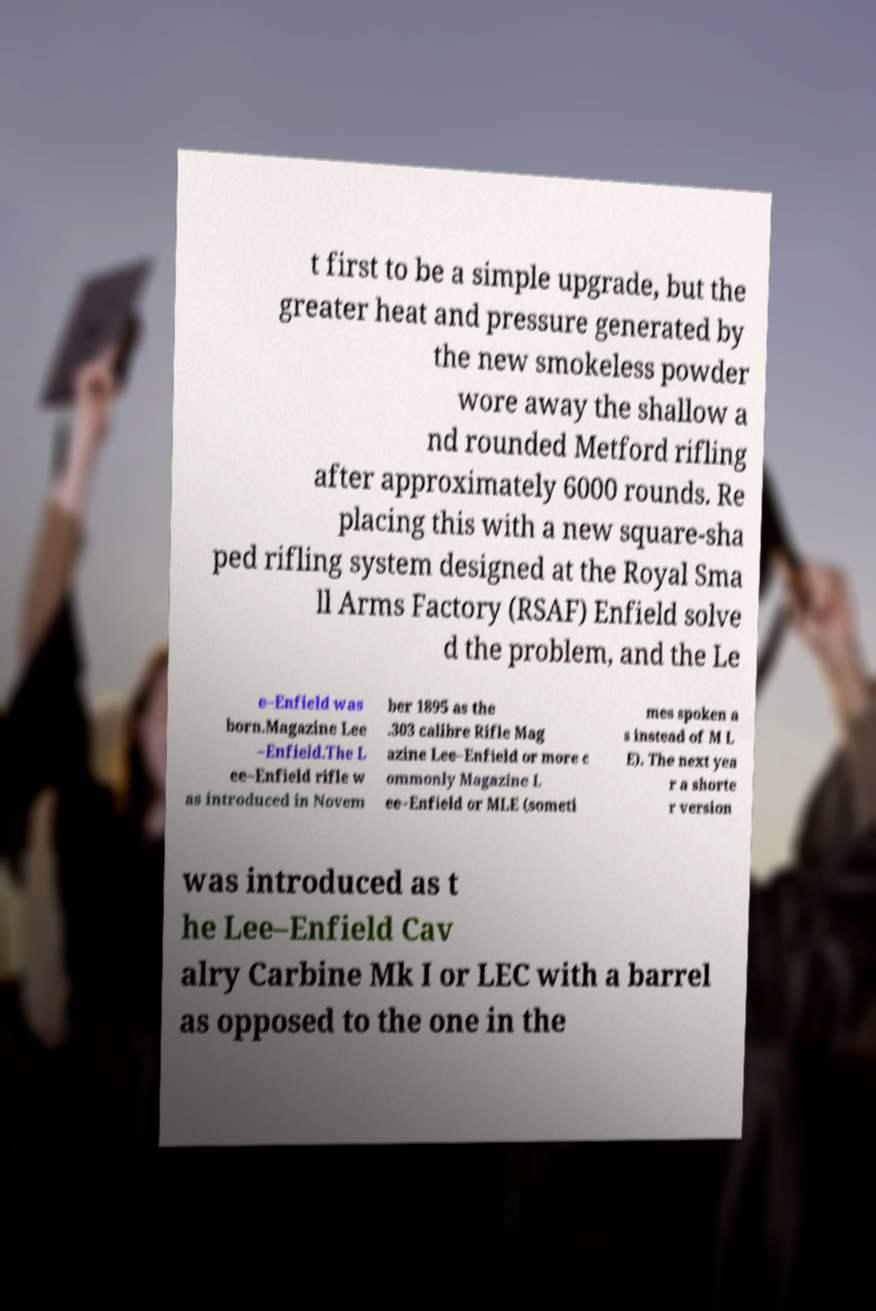Could you assist in decoding the text presented in this image and type it out clearly? t first to be a simple upgrade, but the greater heat and pressure generated by the new smokeless powder wore away the shallow a nd rounded Metford rifling after approximately 6000 rounds. Re placing this with a new square-sha ped rifling system designed at the Royal Sma ll Arms Factory (RSAF) Enfield solve d the problem, and the Le e–Enfield was born.Magazine Lee –Enfield.The L ee–Enfield rifle w as introduced in Novem ber 1895 as the .303 calibre Rifle Mag azine Lee–Enfield or more c ommonly Magazine L ee–Enfield or MLE (someti mes spoken a s instead of M L E). The next yea r a shorte r version was introduced as t he Lee–Enfield Cav alry Carbine Mk I or LEC with a barrel as opposed to the one in the 